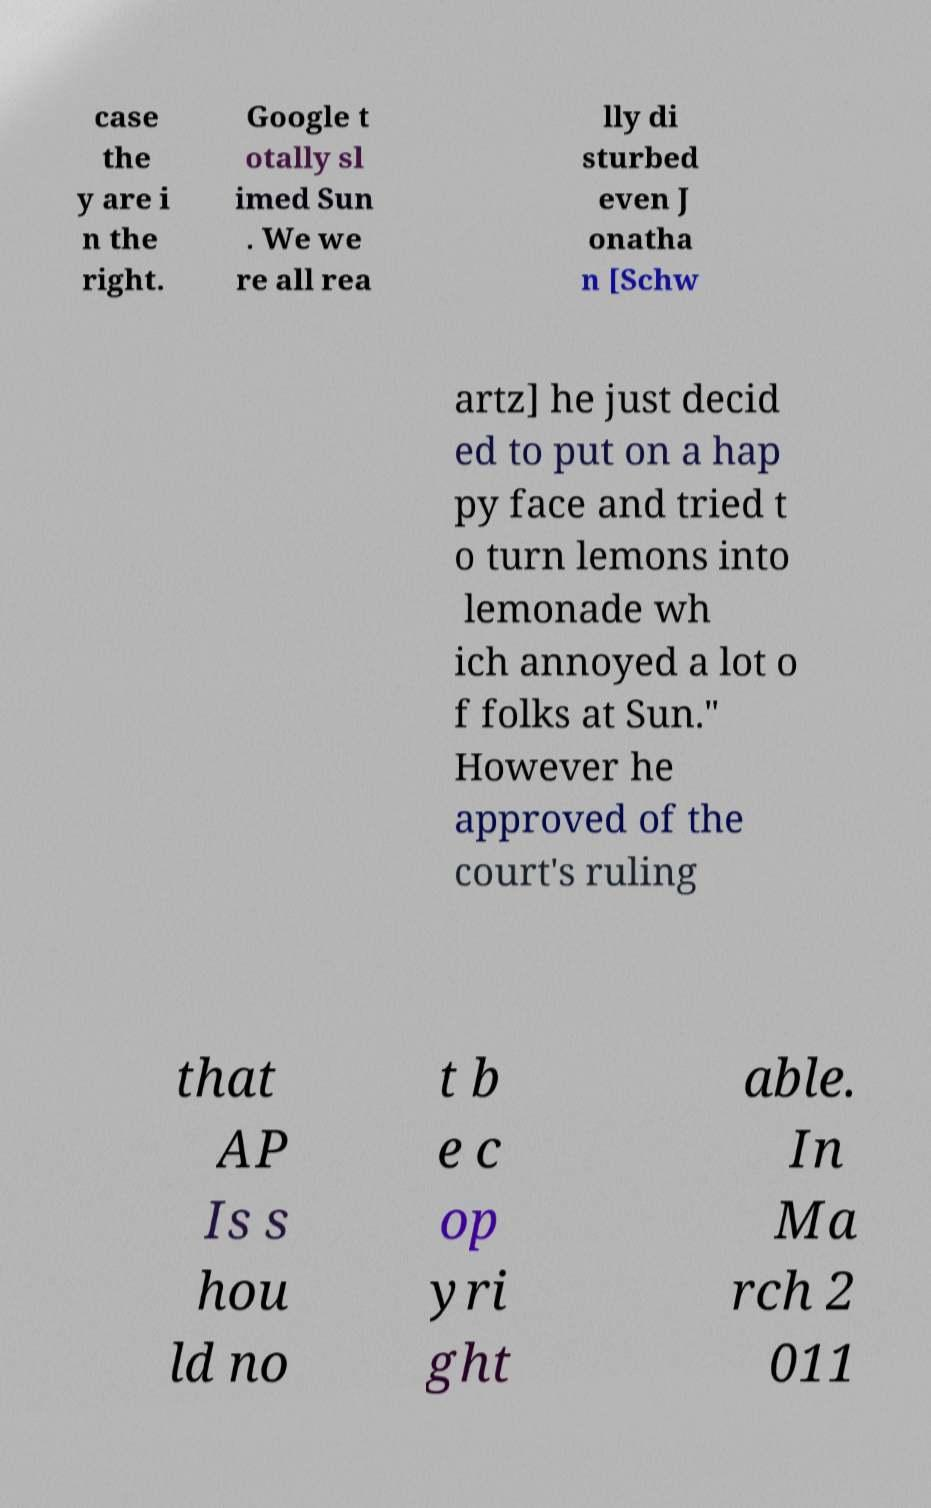Can you read and provide the text displayed in the image?This photo seems to have some interesting text. Can you extract and type it out for me? case the y are i n the right. Google t otally sl imed Sun . We we re all rea lly di sturbed even J onatha n [Schw artz] he just decid ed to put on a hap py face and tried t o turn lemons into lemonade wh ich annoyed a lot o f folks at Sun." However he approved of the court's ruling that AP Is s hou ld no t b e c op yri ght able. In Ma rch 2 011 